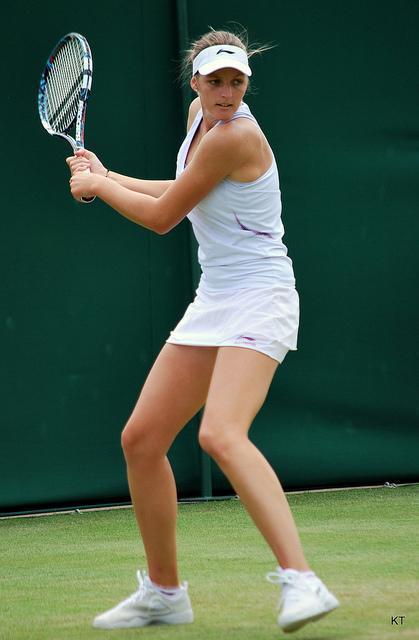How many bears are in the chair?
Give a very brief answer. 0. 